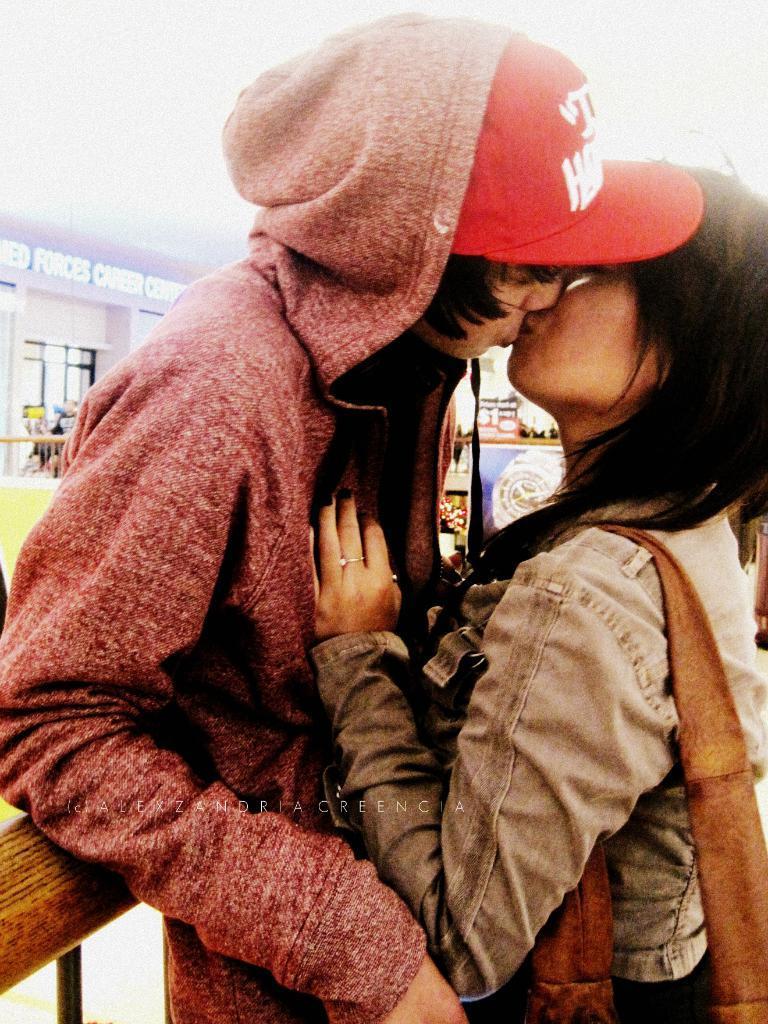Could you give a brief overview of what you see in this image? In the image two persons are kissing. Behind them there is wall and banners. 